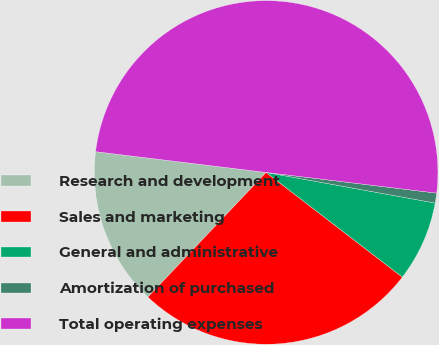Convert chart. <chart><loc_0><loc_0><loc_500><loc_500><pie_chart><fcel>Research and development<fcel>Sales and marketing<fcel>General and administrative<fcel>Amortization of purchased<fcel>Total operating expenses<nl><fcel>14.85%<fcel>26.65%<fcel>7.58%<fcel>0.93%<fcel>50.0%<nl></chart> 